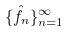<formula> <loc_0><loc_0><loc_500><loc_500>\{ \hat { f } _ { n } \} _ { n = 1 } ^ { \infty }</formula> 